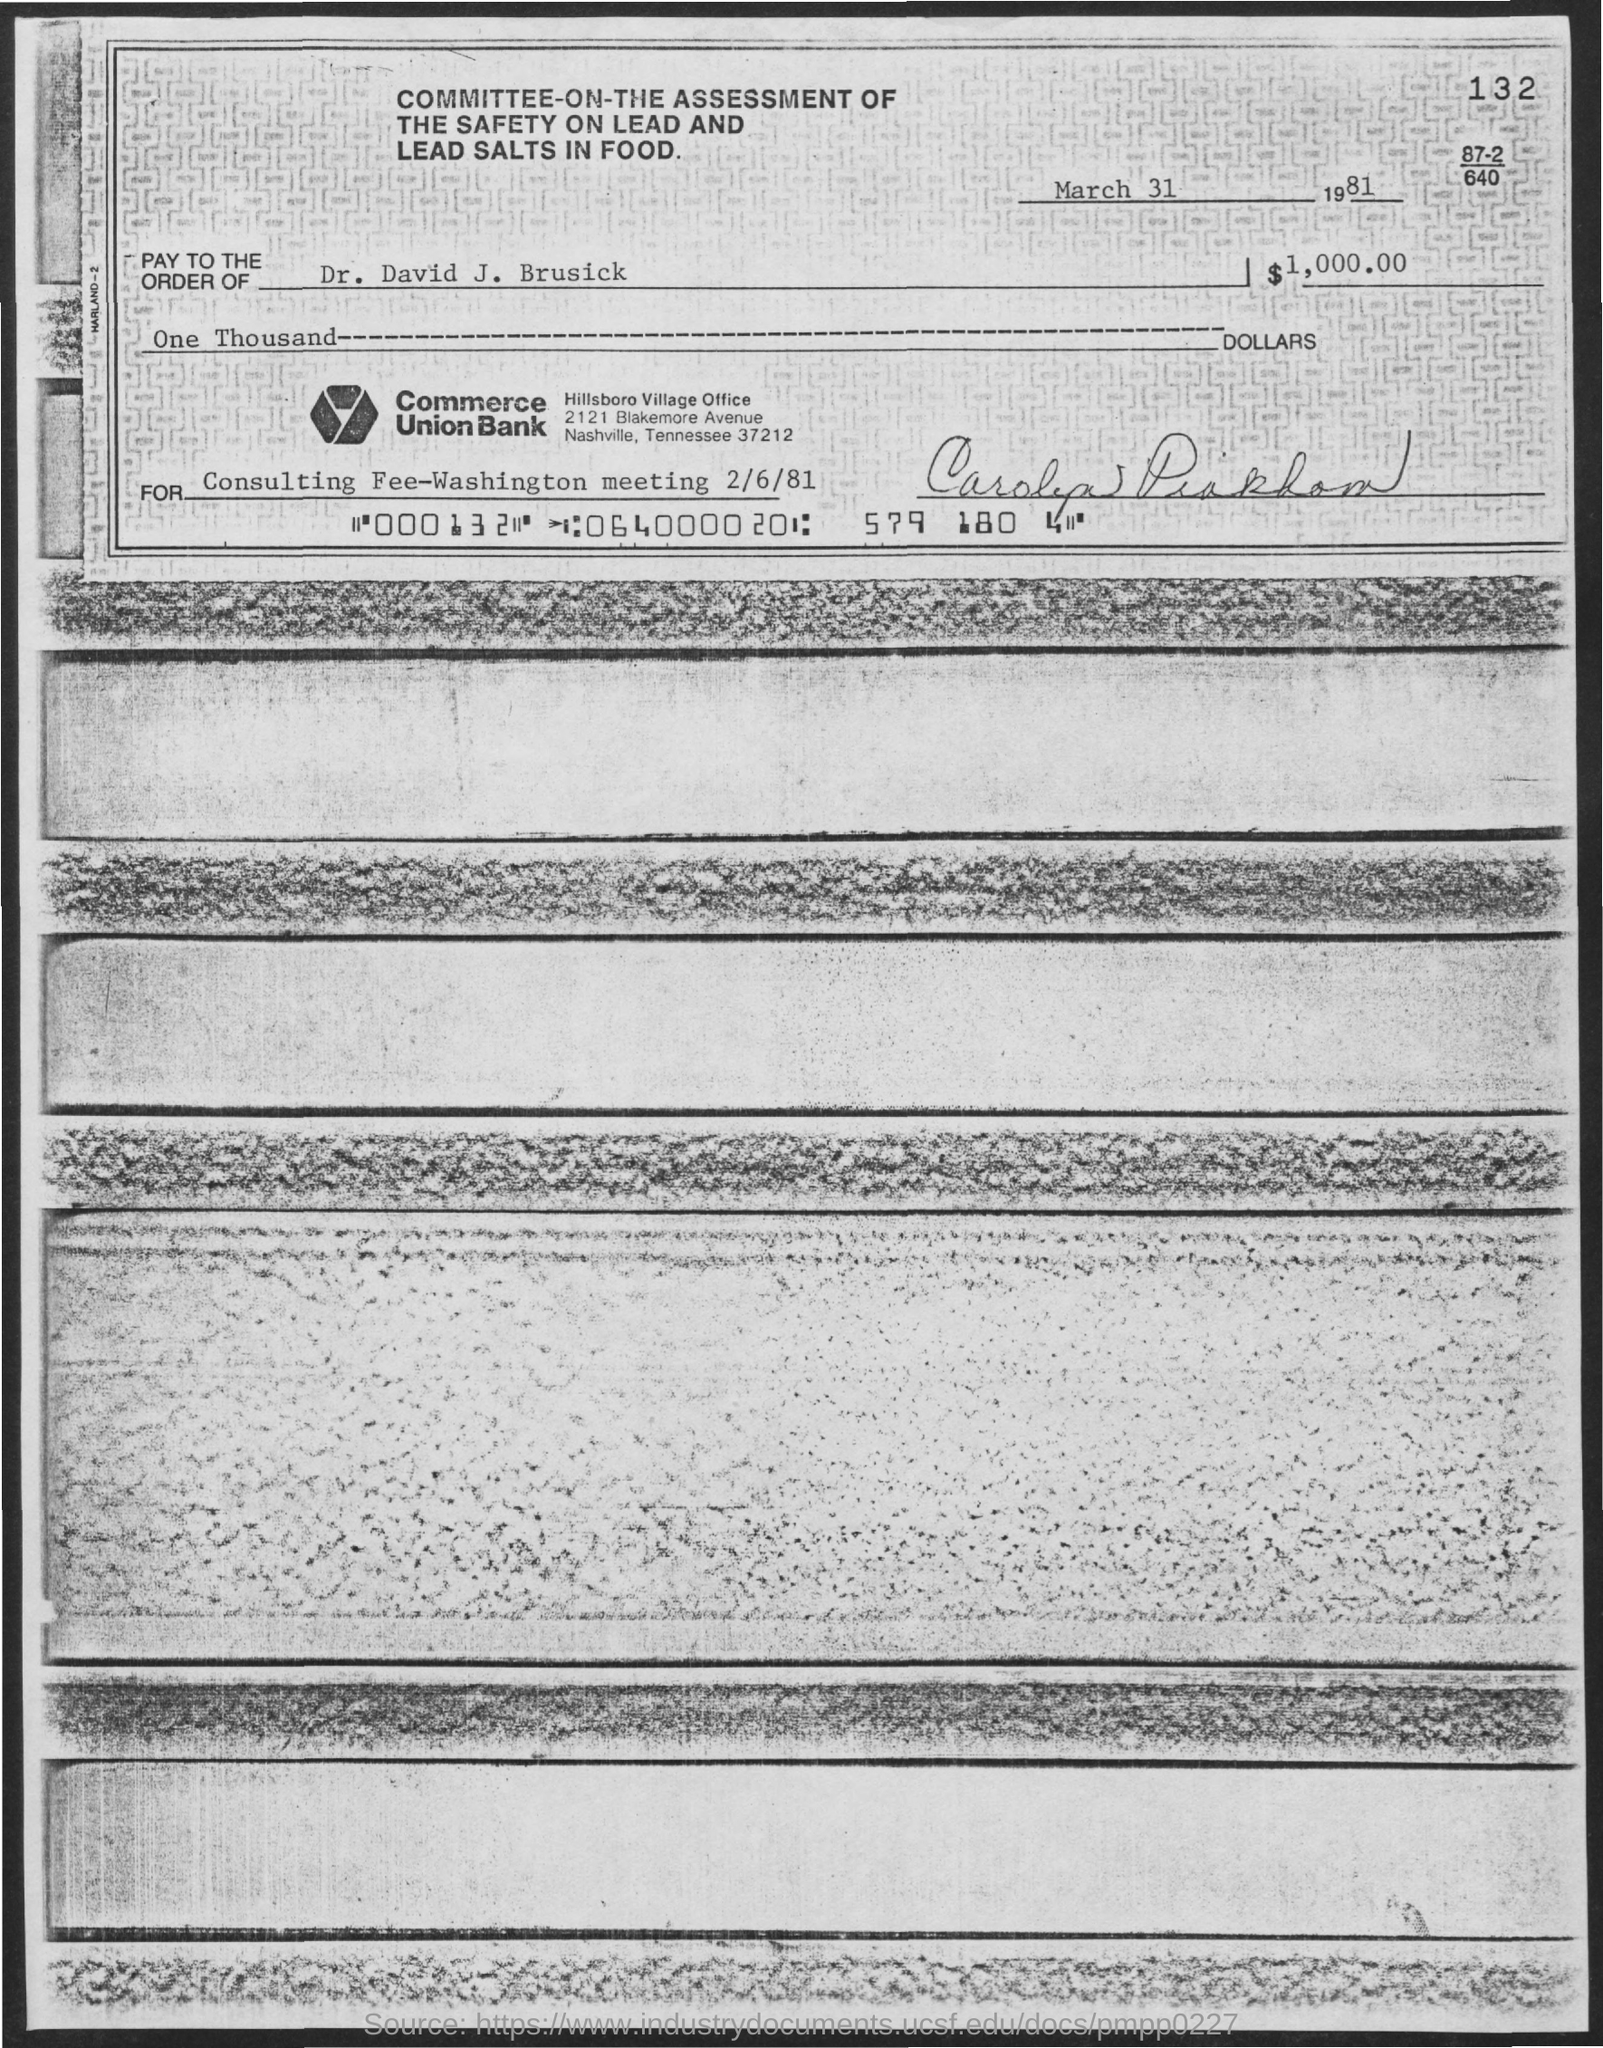What is the title of the document?
Offer a terse response. Committee-on-the assessment of the safety on lead and lead salts in food. What is the date mentioned at the top of the document?
Your answer should be compact. March 31 1981. What is the number at the top right corner of the document?
Give a very brief answer. 132. What is the name of the Village Office?
Keep it short and to the point. Hillsboro Village Office. 